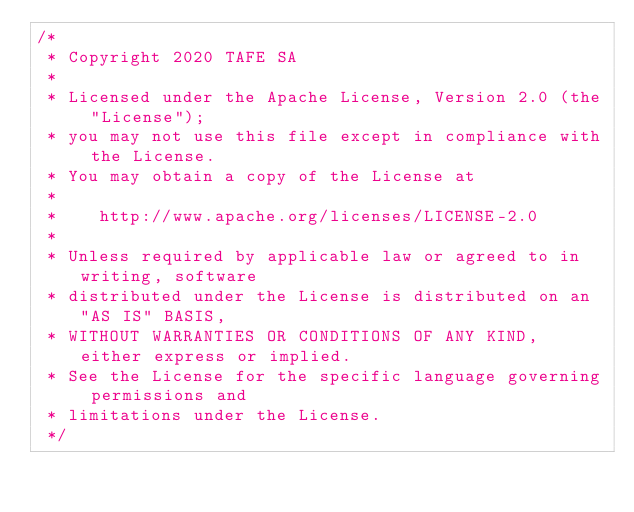Convert code to text. <code><loc_0><loc_0><loc_500><loc_500><_Java_>/*
 * Copyright 2020 TAFE SA
 *
 * Licensed under the Apache License, Version 2.0 (the "License");
 * you may not use this file except in compliance with the License.
 * You may obtain a copy of the License at
 *
 *    http://www.apache.org/licenses/LICENSE-2.0
 *
 * Unless required by applicable law or agreed to in writing, software
 * distributed under the License is distributed on an "AS IS" BASIS,
 * WITHOUT WARRANTIES OR CONDITIONS OF ANY KIND, either express or implied.
 * See the License for the specific language governing permissions and
 * limitations under the License.
 */</code> 